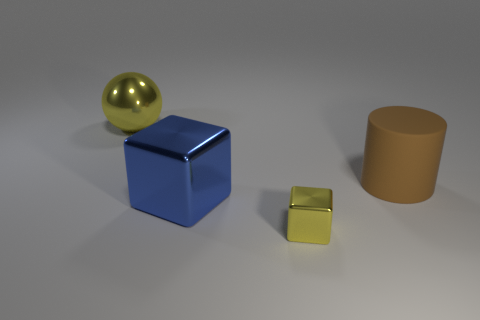Add 2 big metallic spheres. How many objects exist? 6 Subtract all blue blocks. How many blocks are left? 1 Add 1 brown matte cylinders. How many brown matte cylinders are left? 2 Add 3 blue cubes. How many blue cubes exist? 4 Subtract 0 cyan cylinders. How many objects are left? 4 Subtract all blue cylinders. Subtract all cyan blocks. How many cylinders are left? 1 Subtract all red metal spheres. Subtract all rubber cylinders. How many objects are left? 3 